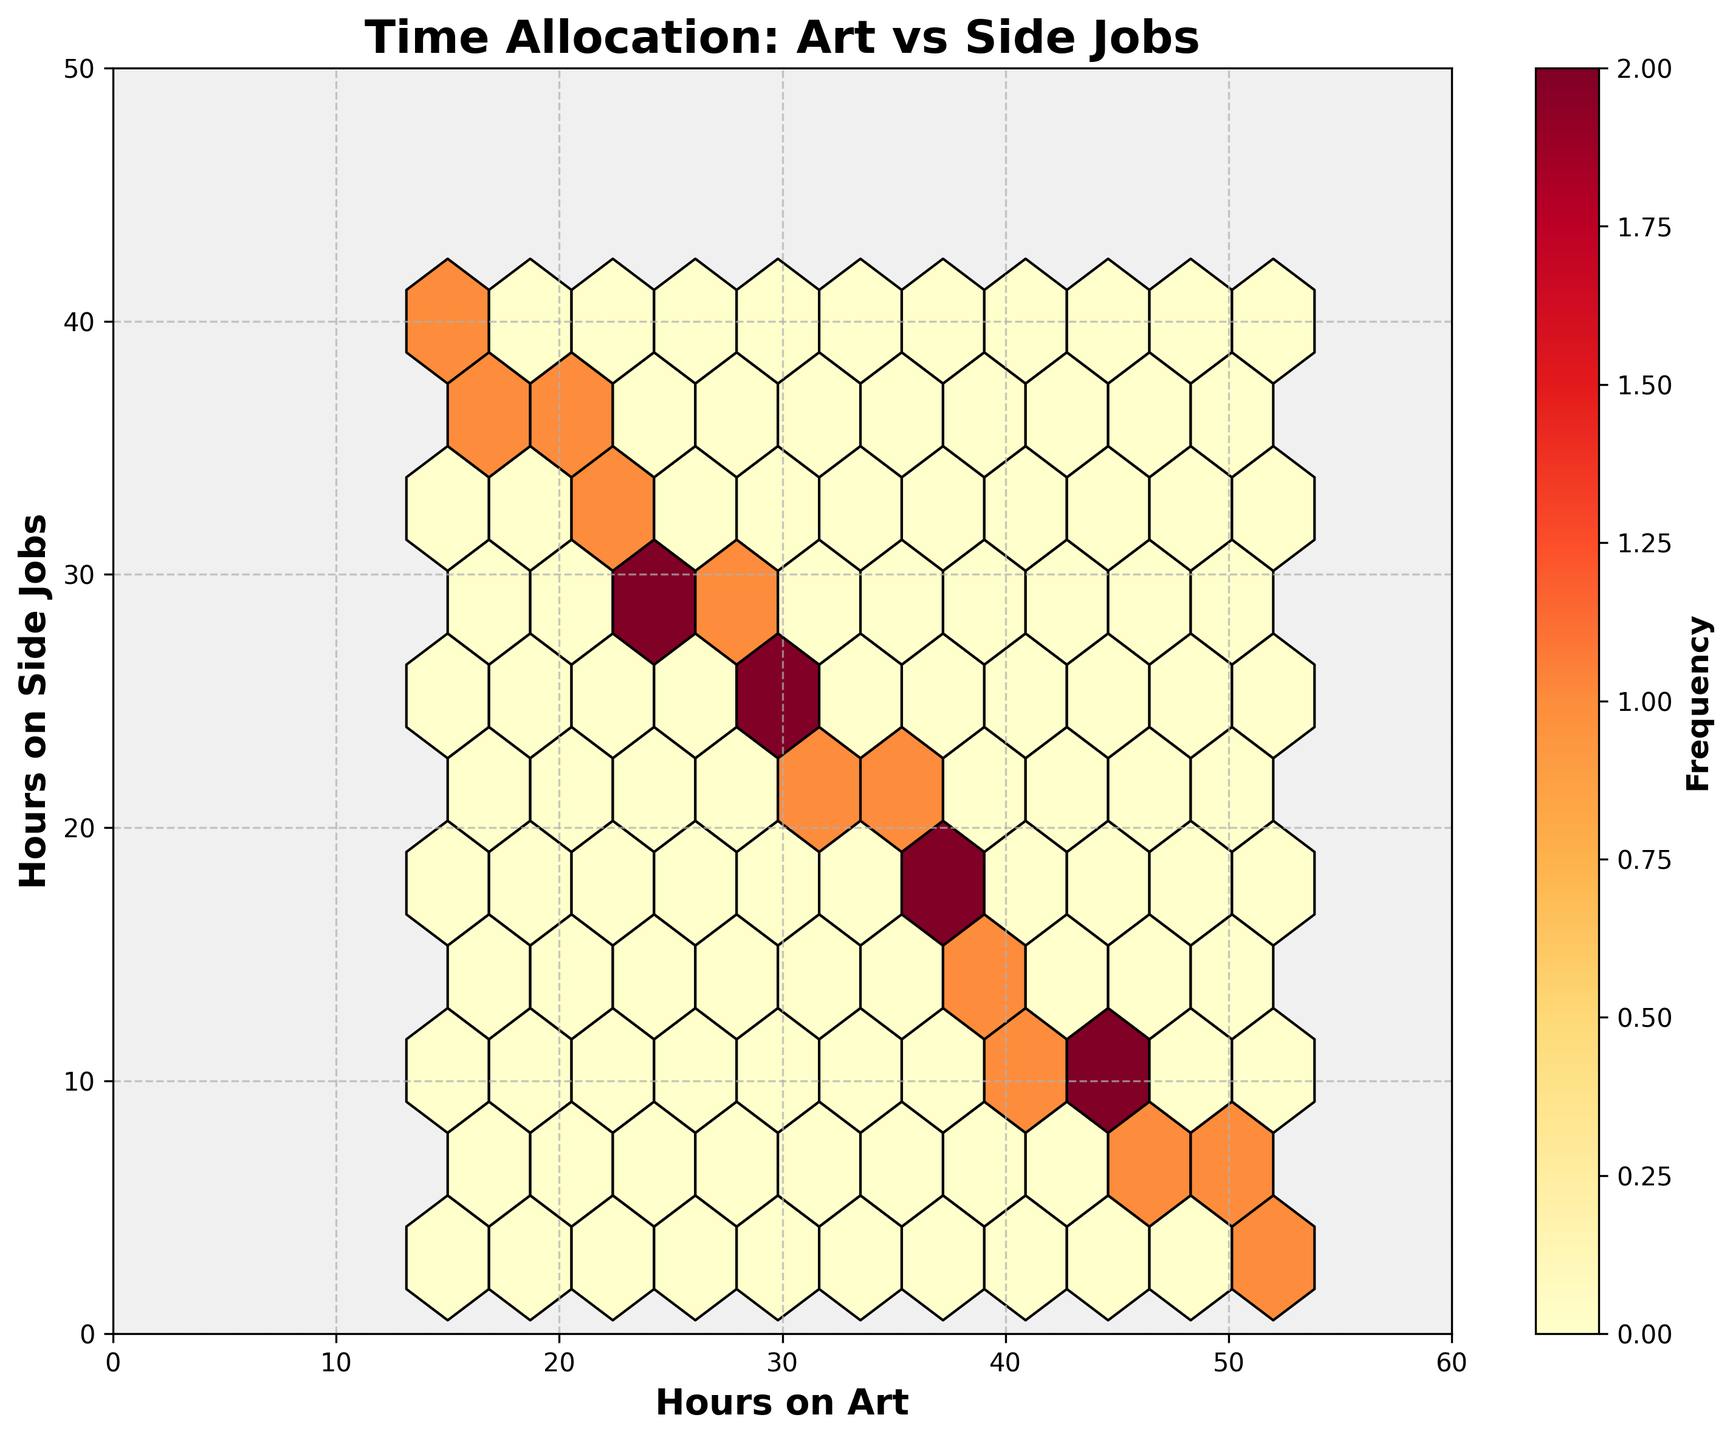What is the title of the plot? The title is displayed at the top of the figure in bold text. It reads "Time Allocation: Art vs Side Jobs".
Answer: Time Allocation: Art vs Side Jobs What are the axes labels? The x-axis label is "Hours on Art" and the y-axis label is "Hours on Side Jobs". These labels are in bold and help to identify what each axis represents.
Answer: Hours on Art and Hours on Side Jobs What is the range of the x-axis and y-axis? The x-axis ranges from 0 to 60 hours, and the y-axis ranges from 0 to 50 hours. These ranges are set to provide a clear display of data.
Answer: 0 to 60 (x-axis) and 0 to 50 (y-axis) Which color represents the highest frequency in the hexbin plot? The color ranging from dark orange to red represents the highest frequencies, as shown by the colorbar on the right side of the figure.
Answer: Dark orange to red Where is the highest concentration of data points? The center of the highest frequency (dark orange to red) is around 35-40 hours on art and 15-20 hours on side jobs. These high-frequency regions display where most data points are clustered.
Answer: Around 35-40 hours on art and 15-20 hours on side jobs What is the lowest number of hours spent on art and side jobs in the dataset? The lowest number of hours spent on art is 15 hours, and the lowest on side jobs is 3 hours. These can be identified by the hexbin's lower boundaries.
Answer: 15 hours on art and 3 hours on side jobs How does the pattern of hours spent on art compare to hours spent on side jobs? Generally, as hours on art increase, hours on side jobs decrease. This inverse relationship is visible by the direction and concentration of hexagons. This indicates many artists spend either more time on art or more on side jobs, but rarely both.
Answer: Inversely related What is the colorbar label and how does it help in interpreting the plot? The colorbar label is 'Frequency', which indicates how frequently data points occur within each hexagon. Darker colors represent higher frequencies, helping to understand data clusters.
Answer: Frequency According to the plot, what range of hours on art has the most variable hours on side jobs? Around 30-40 hours on art, the hours on side jobs vary widely from about 10 to 30 hours, suggesting the highest variability in this range.
Answer: 30-40 hours on art What insight about time allocation priorities among freelance artists can be drawn from this hexbin plot? The plot reveals that freelance artists typically allocate their time distinctly between art and side jobs, with either a high commitment to art and low side jobs or less time on art with high side jobs.
Answer: Distinct allocation patterns 